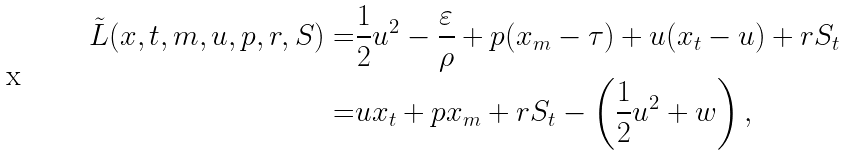Convert formula to latex. <formula><loc_0><loc_0><loc_500><loc_500>\tilde { L } ( x , t , m , u , p , r , S ) = & \frac { 1 } { 2 } u ^ { 2 } - \frac { \varepsilon } { \rho } + p ( x _ { m } - \tau ) + u ( x _ { t } - u ) + r S _ { t } \\ = & u x _ { t } + p x _ { m } + r S _ { t } - \left ( \frac { 1 } { 2 } u ^ { 2 } + w \right ) ,</formula> 